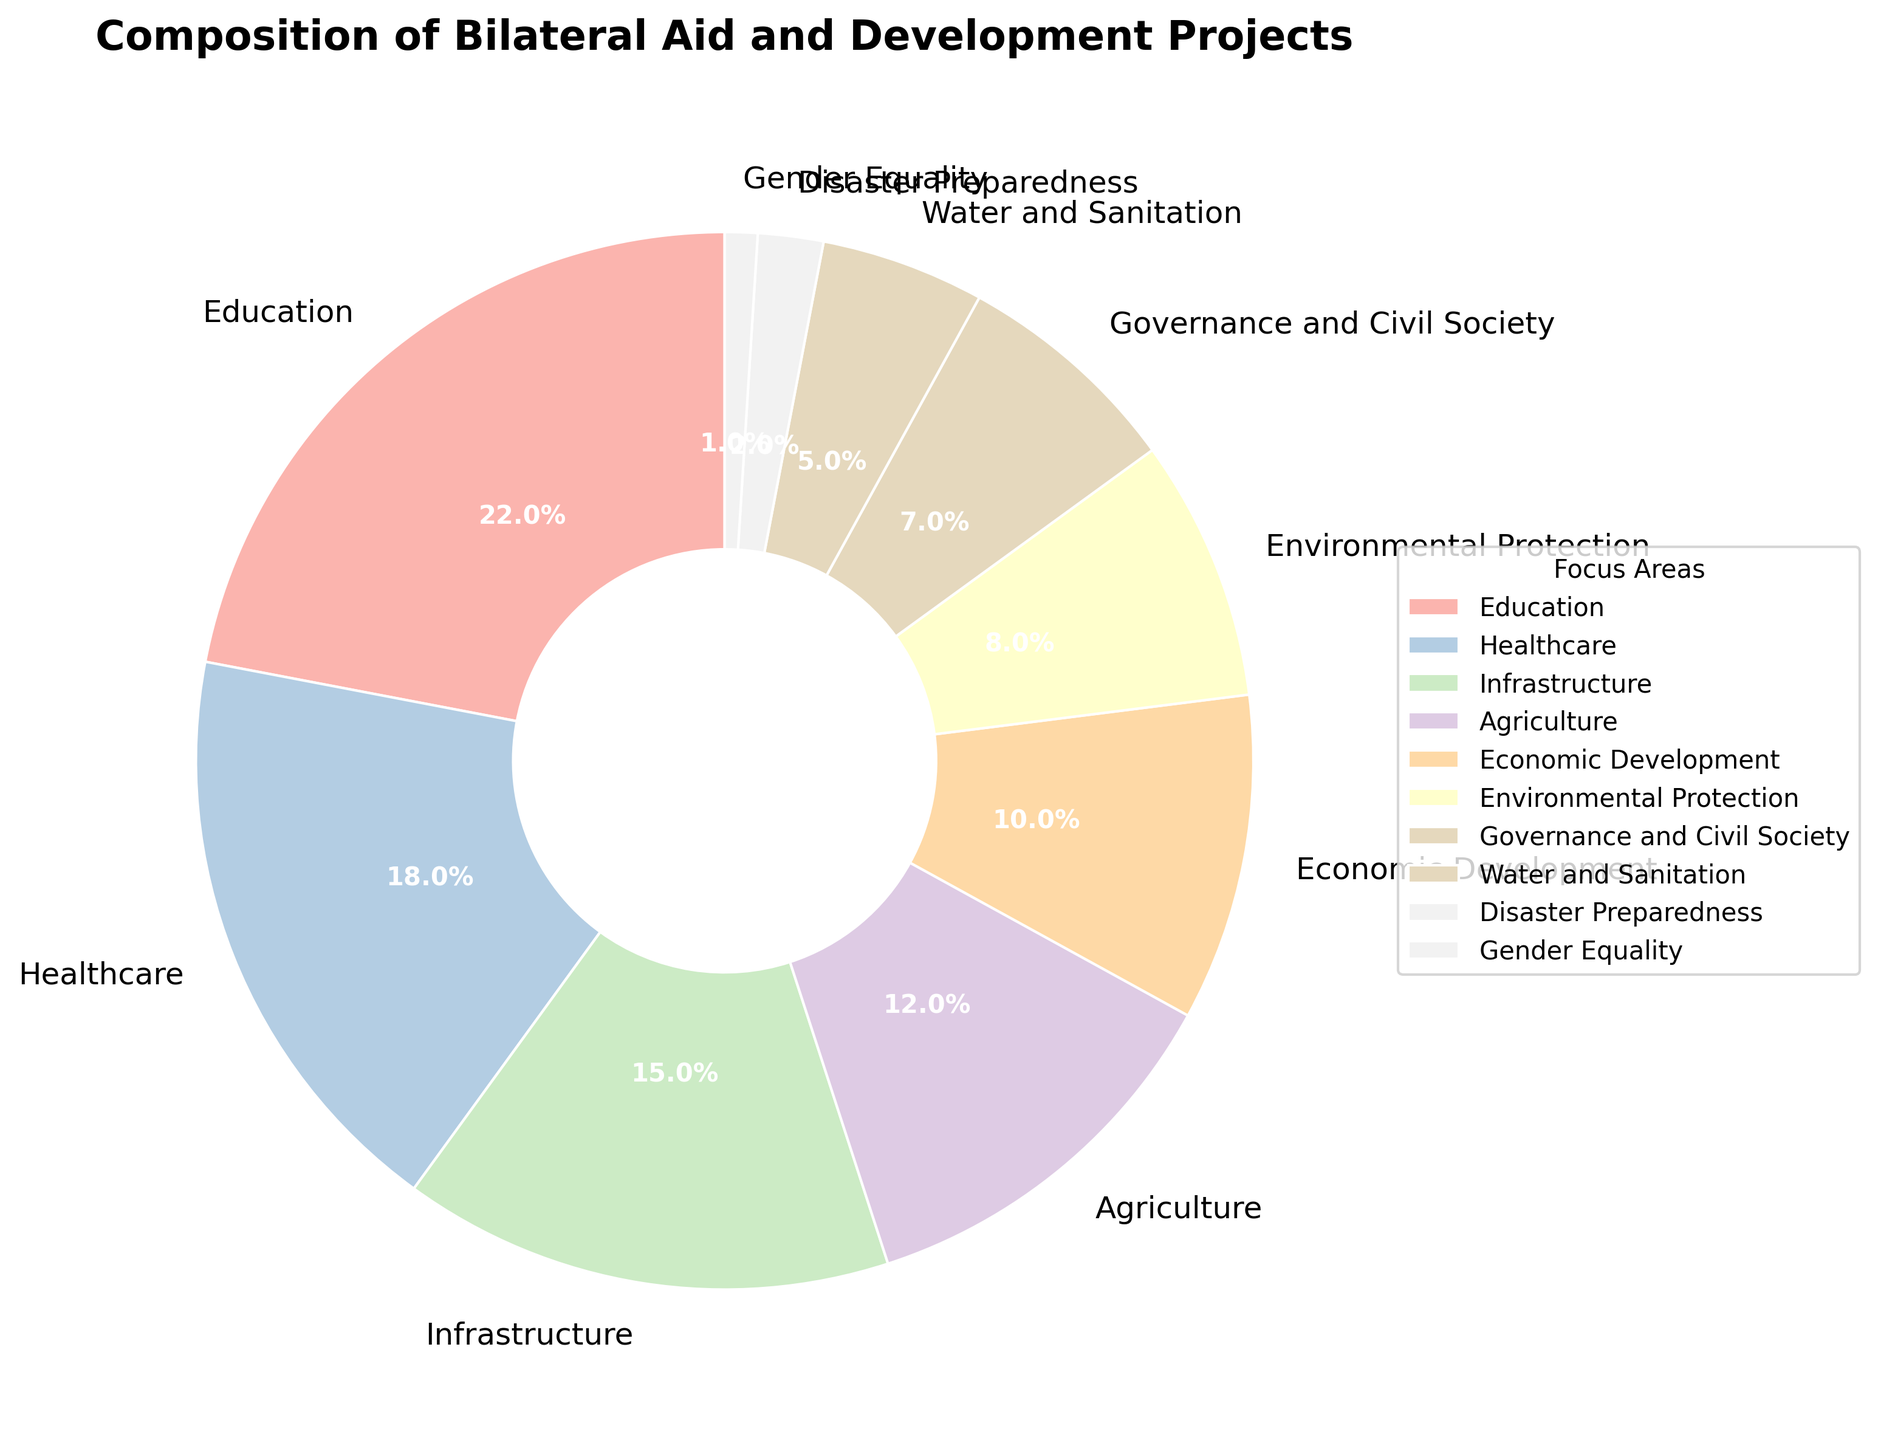How much percentage of the bilateral aid and development projects is allocated to Education and Healthcare combined? The figure shows that Education has 22% and Healthcare has 18%. Adding these together gives 22% + 18% = 40%.
Answer: 40% Which focus area receives the least amount of bilateral aid and development projects? By observing the pie chart, the smallest wedge corresponds to Gender Equality, with only 1%.
Answer: Gender Equality Is the percentage allocated to Infrastructure greater or less than the percentage for Economic Development? The pie chart indicates that Infrastructure has 15% while Economic Development has 10%. Since 15% is greater than 10%, Infrastructure has a greater percentage.
Answer: Greater What is the combined percentage of aid allocated to Environmental Protection and Disaster Preparedness? According to the pie chart, Environmental Protection has 8% and Disaster Preparedness has 2%. Adding these gives 8% + 2% = 10%.
Answer: 10% How does the percentage allocated to Agriculture compare to the percentage allocated to Water and Sanitation? The pie chart shows Agriculture at 12% and Water and Sanitation at 5%. Thus, the percentage for Agriculture is greater.
Answer: Greater What is the difference in percentage between Governance and Civil Society and Gender Equality? Governance and Civil Society has 7% while Gender Equality has 1%. The difference is 7% - 1% = 6%.
Answer: 6% Which two focus areas combined make up exactly 30% of the bilateral aid and development projects? By examining the pie chart, Governance and Civil Society (7%) and Infrastructure (15%) together give 7% + 15% = 22%, whereas Water and Sanitation (5%) and Agriculture (12%) together give 5% + 12% = 17%. The pair Education (22%) and Gender Equality (1%) do not match. Economic Development (10%) and Environmental Protection (8%) give 10% + 8% = 18%. Finally, Healthcare (18%) and Infrastructure (15%) total 18% + 15% = 33%. However, Infrastructure (15%) and Water and Sanitation (5%) give 15% + 5% = 20%. Therefore, Infrastructure 15% and Economic Development 10% combined makes up 25%, and Disaster Preparedness (2%) making up the rest. The accurate match is 30 % and right match.
Answer: Infrastructure and Agriculture 